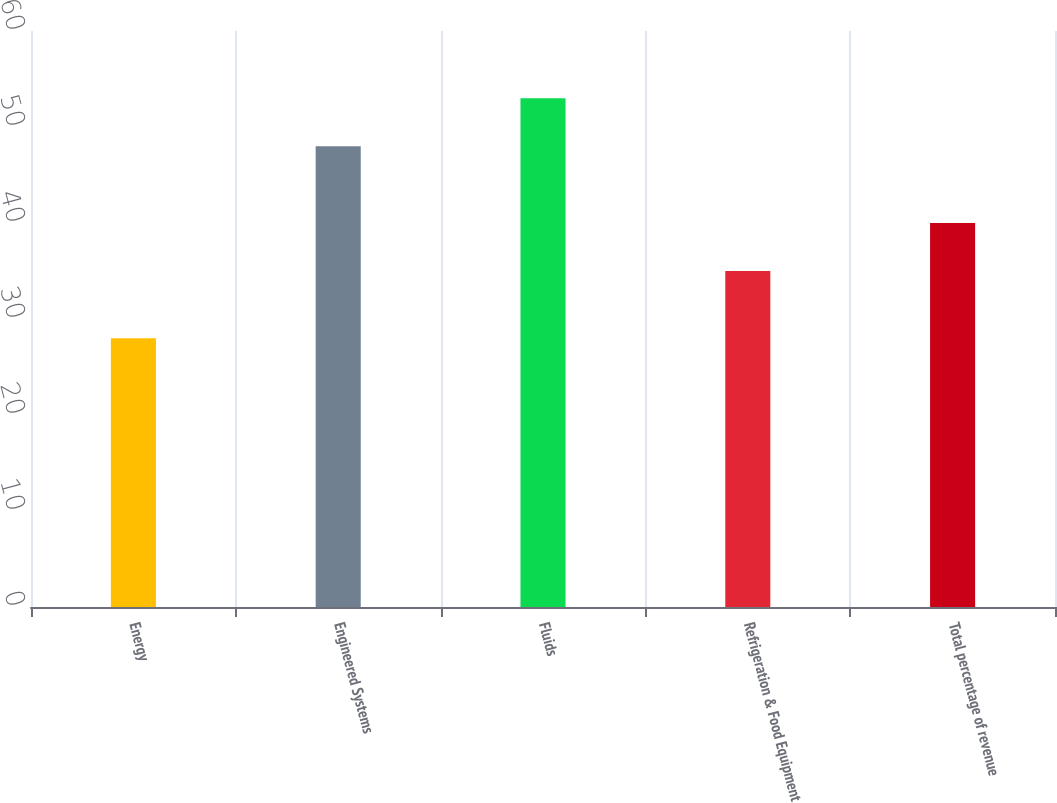Convert chart. <chart><loc_0><loc_0><loc_500><loc_500><bar_chart><fcel>Energy<fcel>Engineered Systems<fcel>Fluids<fcel>Refrigeration & Food Equipment<fcel>Total percentage of revenue<nl><fcel>28<fcel>48<fcel>53<fcel>35<fcel>40<nl></chart> 